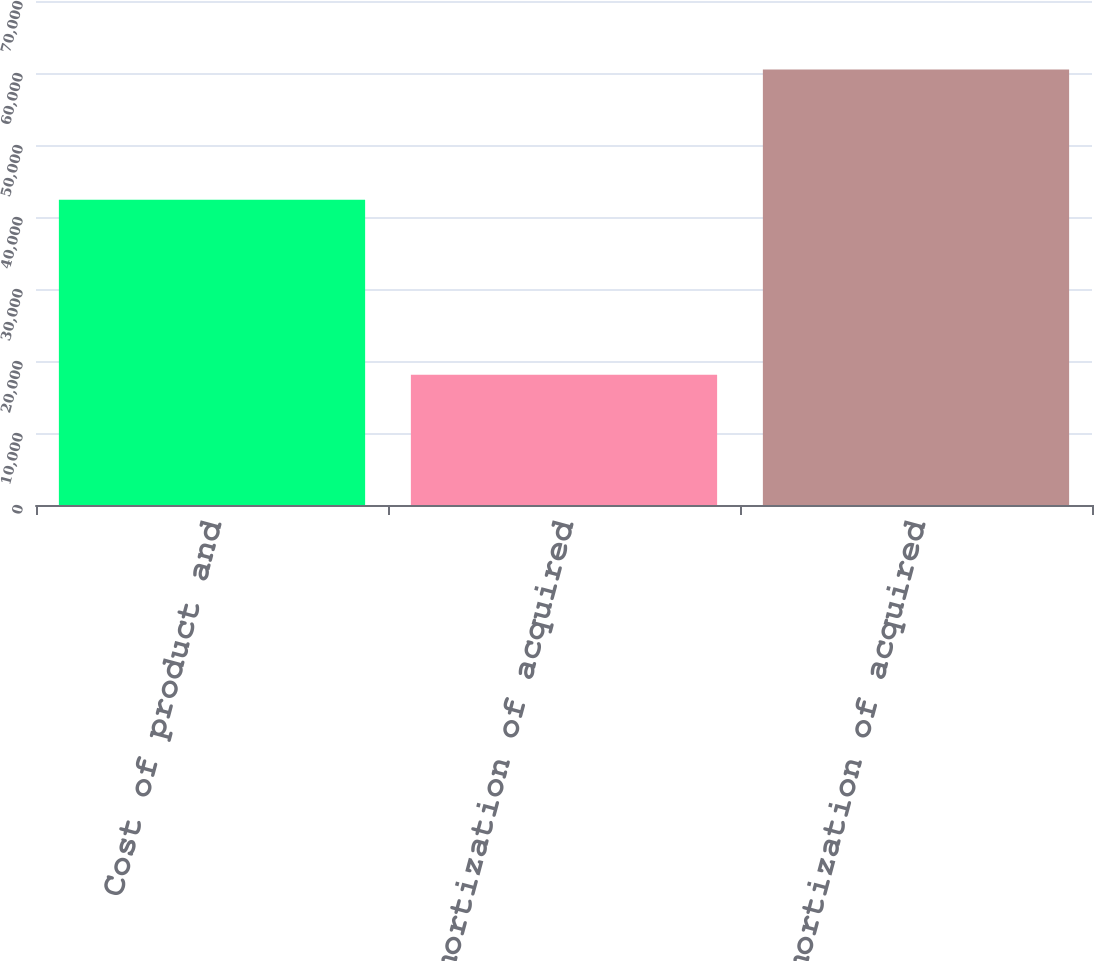<chart> <loc_0><loc_0><loc_500><loc_500><bar_chart><fcel>Cost of product and<fcel>Amortization of acquired<fcel>Total amortization of acquired<nl><fcel>42387<fcel>18095<fcel>60482<nl></chart> 